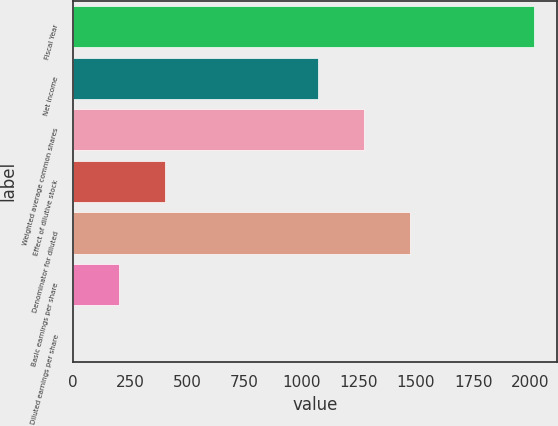<chart> <loc_0><loc_0><loc_500><loc_500><bar_chart><fcel>Fiscal Year<fcel>Net income<fcel>Weighted average common shares<fcel>Effect of dilutive stock<fcel>Denominator for diluted<fcel>Basic earnings per share<fcel>Diluted earnings per share<nl><fcel>2014<fcel>1072<fcel>1273.31<fcel>403.49<fcel>1474.62<fcel>202.18<fcel>0.87<nl></chart> 